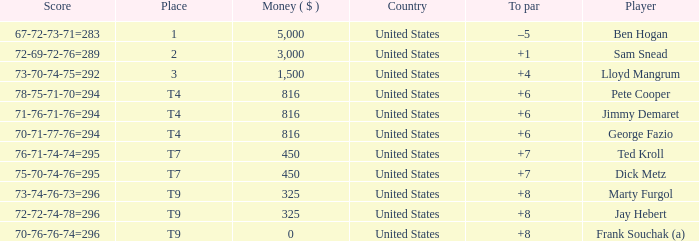What was Marty Furgol's place when he was paid less than $3,000? T9. 